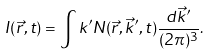Convert formula to latex. <formula><loc_0><loc_0><loc_500><loc_500>I ( \vec { r } , t ) = \int k ^ { \prime } N ( \vec { r } , \vec { k } ^ { \prime } , t ) \frac { d \vec { k } ^ { \prime } } { ( 2 \pi ) ^ { 3 } } .</formula> 